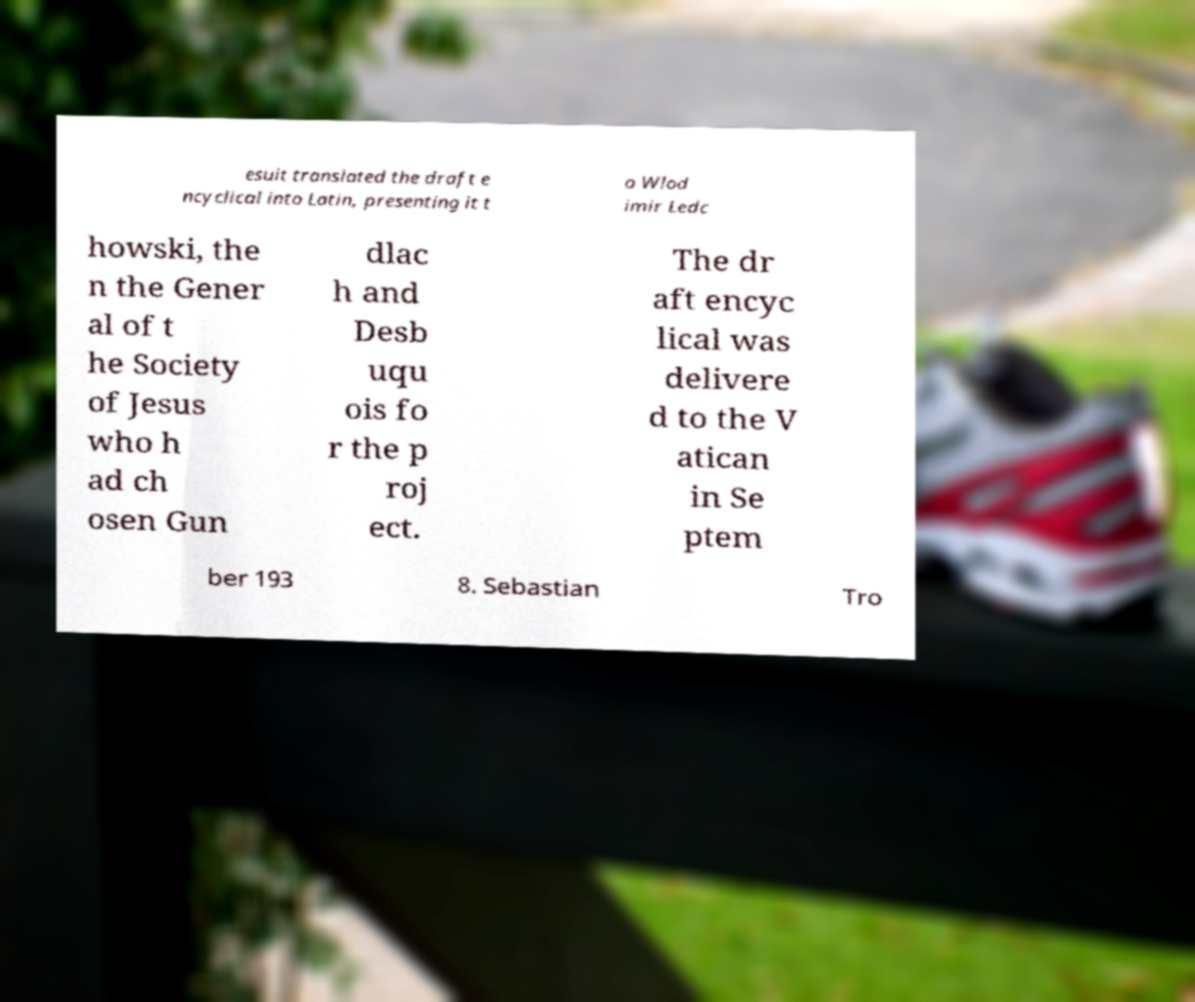Please read and relay the text visible in this image. What does it say? esuit translated the draft e ncyclical into Latin, presenting it t o Wlod imir Ledc howski, the n the Gener al of t he Society of Jesus who h ad ch osen Gun dlac h and Desb uqu ois fo r the p roj ect. The dr aft encyc lical was delivere d to the V atican in Se ptem ber 193 8. Sebastian Tro 